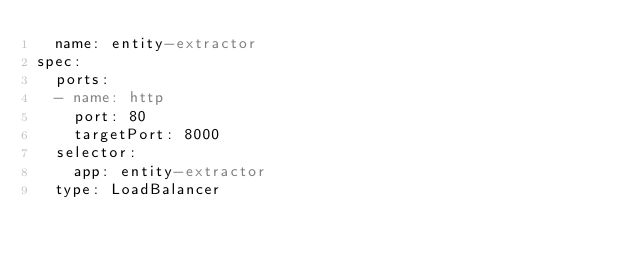<code> <loc_0><loc_0><loc_500><loc_500><_YAML_>  name: entity-extractor
spec:
  ports:
  - name: http
    port: 80
    targetPort: 8000
  selector:
    app: entity-extractor
  type: LoadBalancer
</code> 